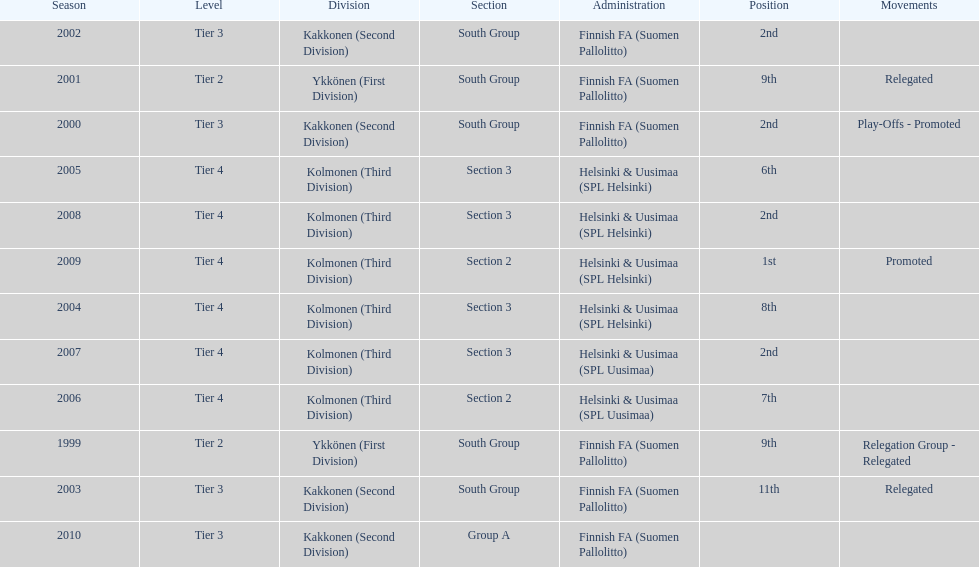What division were they in the most, section 3 or 2? 3. 